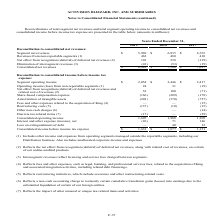According to Activision Blizzard's financial document, What do intersegment revenues reflect? licensing and service fees charged between segments.. The document states: "(3) Intersegment revenues reflect licensing and service fees charged between segments...." Also, What was the segment net revenue in 2019? According to the financial document, $5,969 (in millions). The relevant text states: "consolidated net revenues: Segment net revenues $ 5,969 $ 6,835 $ 6,765..." Also, What was the revenues from non-reportable segments in 2017? According to the financial document, 410 (in millions). The relevant text states: "Revenues from non-reportable segments (1) 462 480 410..." Also, can you calculate: What was the percentage change in segment net revenues between 2018 and 2019? To answer this question, I need to perform calculations using the financial data. The calculation is: ($5,969-$6,835)/$6,835, which equals -12.67 (percentage). This is based on the information: "ated net revenues: Segment net revenues $ 5,969 $ 6,835 $ 6,765 consolidated net revenues: Segment net revenues $ 5,969 $ 6,835 $ 6,765..." The key data points involved are: 5,969, 6,835. Also, can you calculate: What was the percentage change in segment operating income before income tax expense between 2017 and 2018? To answer this question, I need to perform calculations using the financial data. The calculation is: ($2,446-$2,417)/$2,417, which equals 1.2 (percentage). This is based on the information: "pense: Segment operating income $ 2,054 $ 2,446 $ 2,417 e tax expense: Segment operating income $ 2,054 $ 2,446 $ 2,417..." The key data points involved are: 2,417, 2,446. Also, can you calculate: What was the change in consolidated net revenues between 2018 and 2019? Based on the calculation: ($6,489-$7,500), the result is -1011 (in millions). This is based on the information: "Consolidated net revenues $ 6,489 $ 7,500 $ 7,017 Consolidated net revenues $ 6,489 $ 7,500 $ 7,017..." The key data points involved are: 6,489, 7,500. 